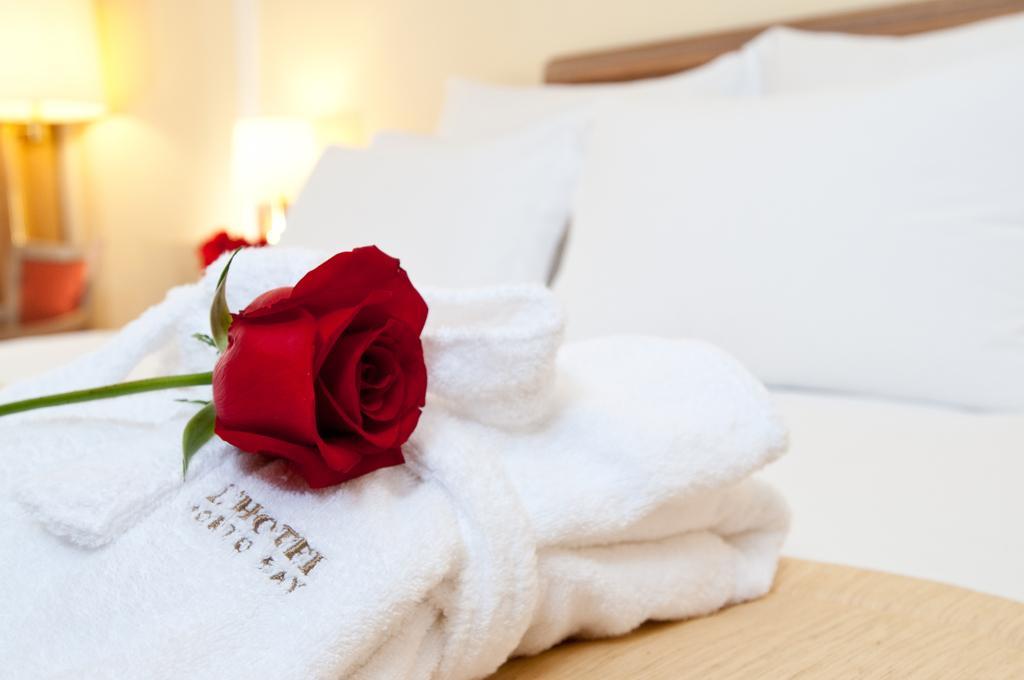Describe this image in one or two sentences. In this image there is a bed, on the bed there are bed sheets, rose flower kept on bed sheet, in the top left there are lamps, wall. 